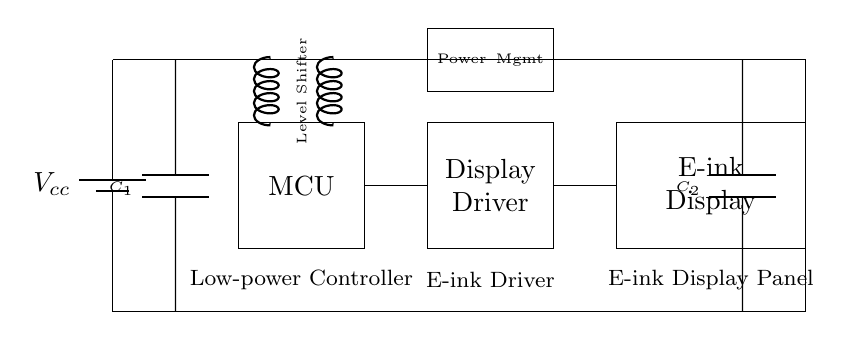What is the power supply voltage in this circuit? The power supply voltage is indicated by the label next to the battery symbol, which shows V subscript cc as the supply voltage.
Answer: Vcc What does the box labeled "MCU" stand for? The box labeled "MCU" represents the microcontroller, as indicated directly by the label within the rectangle.
Answer: Microcontroller How many decoupling capacitors are present in the circuit? There are two decoupling capacitors, labeled C1 and C2, shown connected to the power supply lines.
Answer: Two What is the function of the component labeled "Level Shifter"? The level shifter allows for voltage level adjustments between the microcontroller and the display driver, facilitating communication with different voltage levels.
Answer: Voltage adjustment What is the role of the "Power Mgmt" block in this circuit? The power management block, labeled as "Power Mgmt," is responsible for regulating the power supply to the display driver and the overall management of power usage in the circuit.
Answer: Power regulation Which component directly connects to the e-ink display? The display driver is the component that directly connects to the e-ink display, as indicated by the line connecting them in the diagram.
Answer: Display Driver What type of display is represented in the circuit? The display type is specified by the label on the rectangle, which states it is an "E-ink Display," indicating the technology used for the screen.
Answer: E-ink Display 